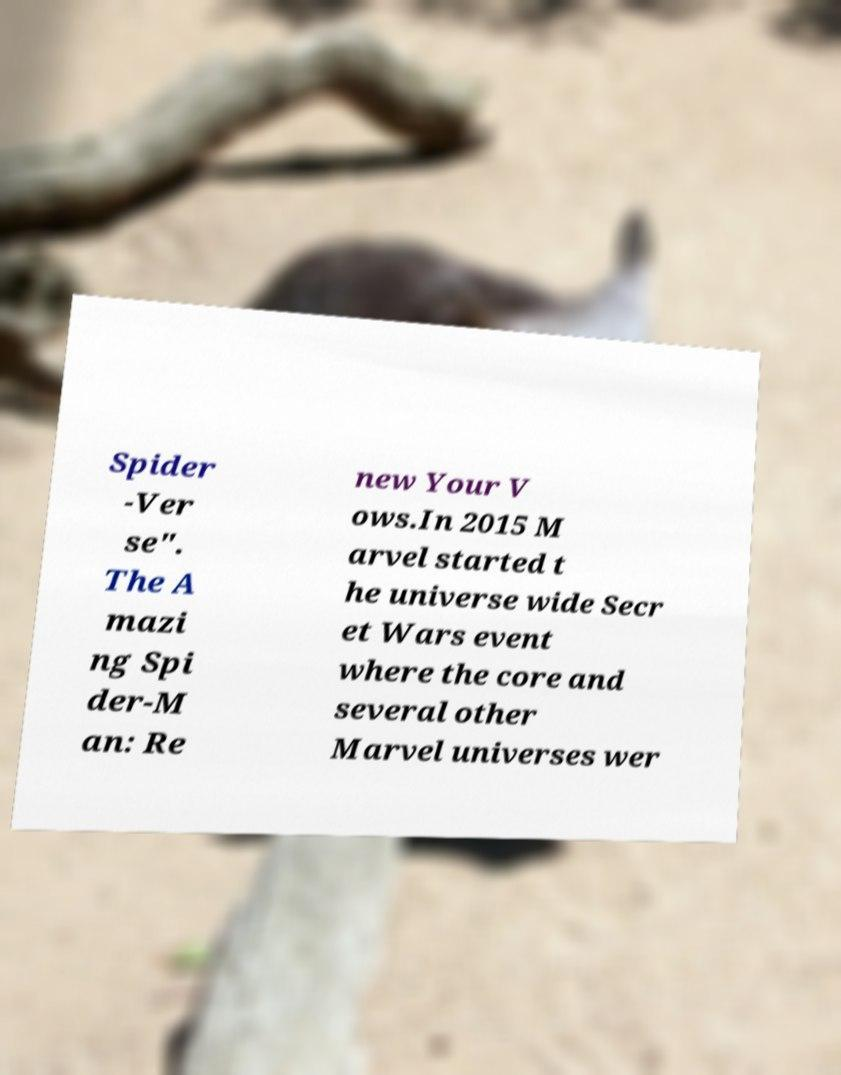What messages or text are displayed in this image? I need them in a readable, typed format. Spider -Ver se". The A mazi ng Spi der-M an: Re new Your V ows.In 2015 M arvel started t he universe wide Secr et Wars event where the core and several other Marvel universes wer 